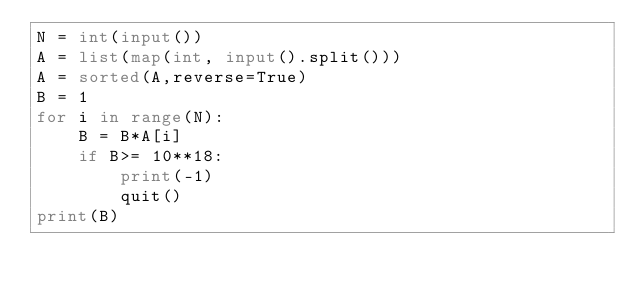<code> <loc_0><loc_0><loc_500><loc_500><_Python_>N = int(input())
A = list(map(int, input().split()))
A = sorted(A,reverse=True)
B = 1
for i in range(N):
    B = B*A[i]
    if B>= 10**18:  
        print(-1)
        quit()
print(B)</code> 